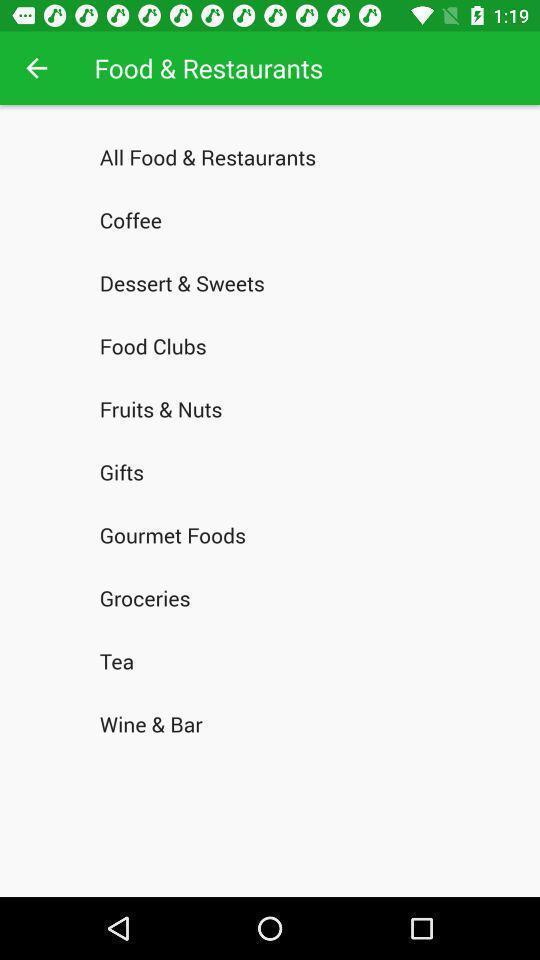What is the overall content of this screenshot? Page shows various menu options of food and restaurants app. 